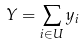Convert formula to latex. <formula><loc_0><loc_0><loc_500><loc_500>Y = \sum _ { i \in U } y _ { i }</formula> 